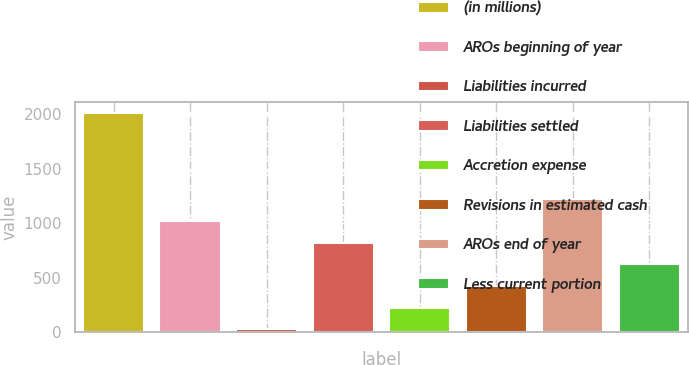Convert chart to OTSL. <chart><loc_0><loc_0><loc_500><loc_500><bar_chart><fcel>(in millions)<fcel>AROs beginning of year<fcel>Liabilities incurred<fcel>Liabilities settled<fcel>Accretion expense<fcel>Revisions in estimated cash<fcel>AROs end of year<fcel>Less current portion<nl><fcel>2012<fcel>1019.9<fcel>27.8<fcel>821.48<fcel>226.22<fcel>424.64<fcel>1218.32<fcel>623.06<nl></chart> 